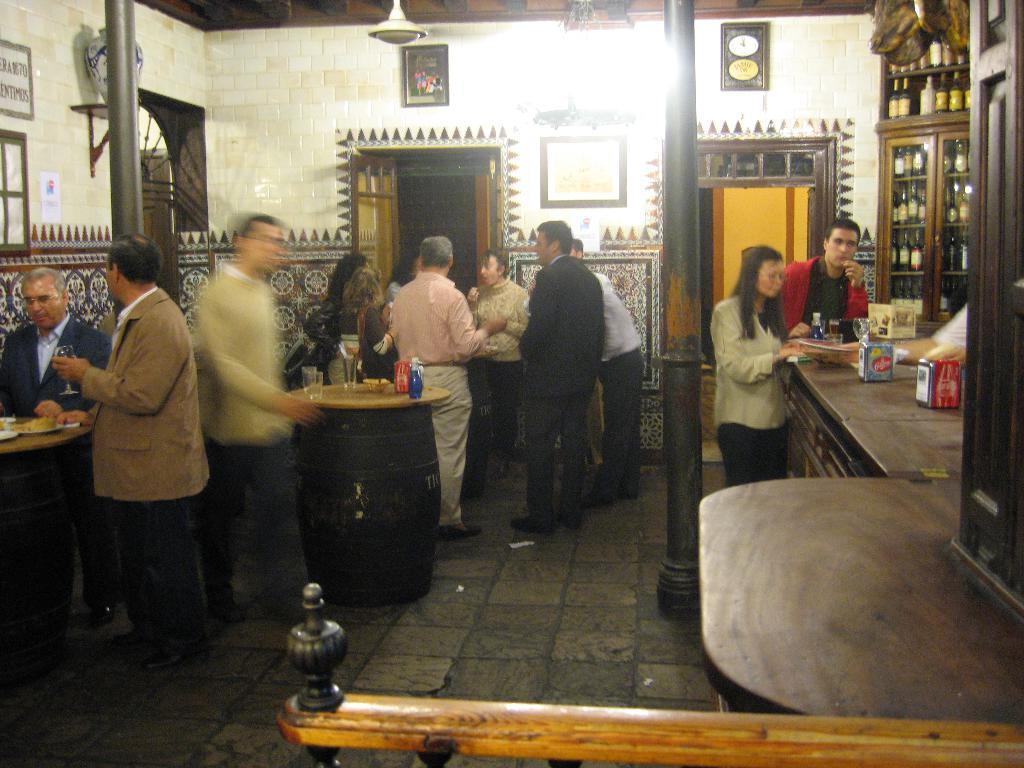How many people are in the group visible in the image? There is a group of people standing in the image, but the exact number cannot be determined from the provided facts. What is located on the right side of the image? There is a table on the right side of the image. Where are the wine bottles placed in the image? The wine bottles are arranged on a shelf in the image. How many apples are hanging from the ornament in the image? There is no ornament or apples present in the image. What type of sail can be seen in the background of the image? There is no sail visible in the image; it does not depict any outdoor or maritime scenes. 